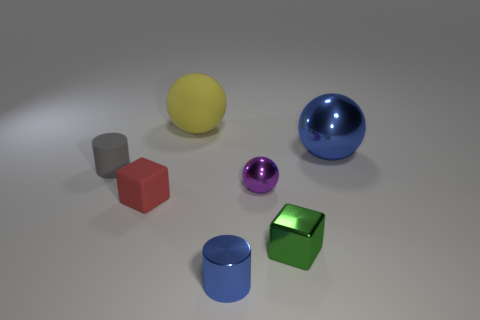Add 3 small yellow things. How many objects exist? 10 Subtract all spheres. How many objects are left? 4 Add 2 small gray matte objects. How many small gray matte objects are left? 3 Add 3 red metallic blocks. How many red metallic blocks exist? 3 Subtract 0 brown cubes. How many objects are left? 7 Subtract all small yellow rubber blocks. Subtract all tiny green cubes. How many objects are left? 6 